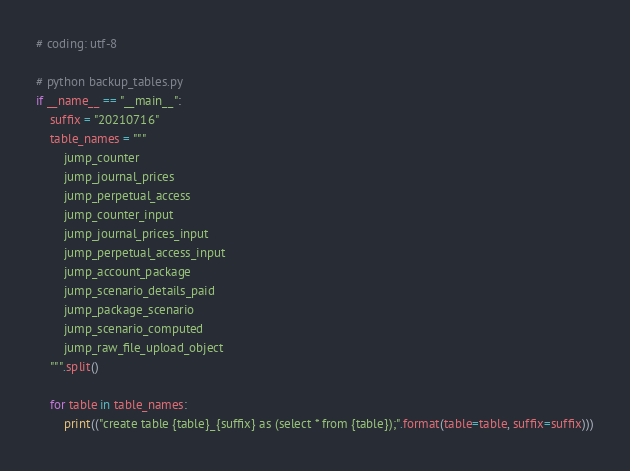<code> <loc_0><loc_0><loc_500><loc_500><_Python_># coding: utf-8

# python backup_tables.py
if __name__ == "__main__":
    suffix = "20210716"
    table_names = """
        jump_counter
        jump_journal_prices
        jump_perpetual_access
        jump_counter_input
        jump_journal_prices_input
        jump_perpetual_access_input
        jump_account_package
        jump_scenario_details_paid
        jump_package_scenario
        jump_scenario_computed
        jump_raw_file_upload_object
    """.split()

    for table in table_names:
        print(("create table {table}_{suffix} as (select * from {table});".format(table=table, suffix=suffix)))

</code> 